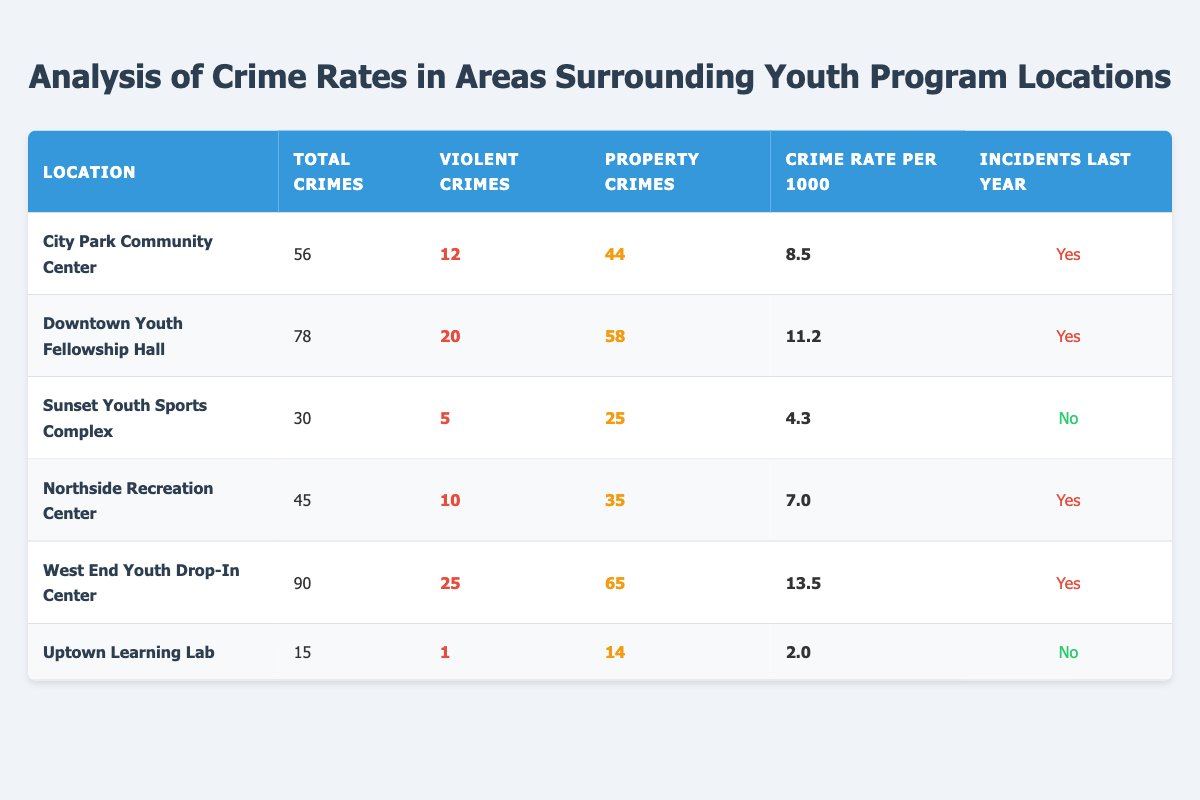What is the total number of crimes reported at the West End Youth Drop-In Center? The table shows that the total number of crimes reported at the West End Youth Drop-In Center is 90.
Answer: 90 How many violent crimes were reported at the Downtown Youth Fellowship Hall? The table indicates that there were 20 violent crimes reported at the Downtown Youth Fellowship Hall.
Answer: 20 Which location has the highest crime rate per 1000? Comparing the crime rates in the table, the West End Youth Drop-In Center has the highest crime rate at 13.5 per 1000.
Answer: 13.5 What is the total number of property crimes across all locations? Adding the property crimes from each location results in 44 + 58 + 25 + 35 + 65 + 14 = 241 property crimes in total.
Answer: 241 Did the Sunset Youth Sports Complex report any incidents last year? According to the table, the Sunset Youth Sports Complex did not report any incidents last year, as indicated by "No".
Answer: No What is the crime rate difference between the City Park Community Center and the Uptown Learning Lab? The crime rate at the City Park Community Center is 8.5, and at the Uptown Learning Lab, it is 2.0. The difference is 8.5 - 2.0 = 6.5.
Answer: 6.5 Which location has more violent crimes, Northside Recreation Center or City Park Community Center? The Northside Recreation Center reported 10 violent crimes while City Park Community Center reported 12. Since 12 > 10, City Park Community Center has more violent crimes.
Answer: City Park Community Center How many locations reported incidents last year? By checking the table, the locations that reported incidents are City Park Community Center, Downtown Youth Fellowship Hall, Northside Recreation Center, and West End Youth Drop-In Center, totaling 4 locations.
Answer: 4 What is the average number of total crimes across all locations? The total crimes are 56 + 78 + 30 + 45 + 90 + 15 = 314 across 6 locations. The average is 314 / 6 = approximately 52.33.
Answer: 52.33 Is the number of violent crimes at the Sunset Youth Sports Complex greater than that at the Uptown Learning Lab? The Sunset Youth Sports Complex has 5 violent crimes, while the Uptown Learning Lab has only 1. Since 5 > 1, the statement is true.
Answer: Yes 